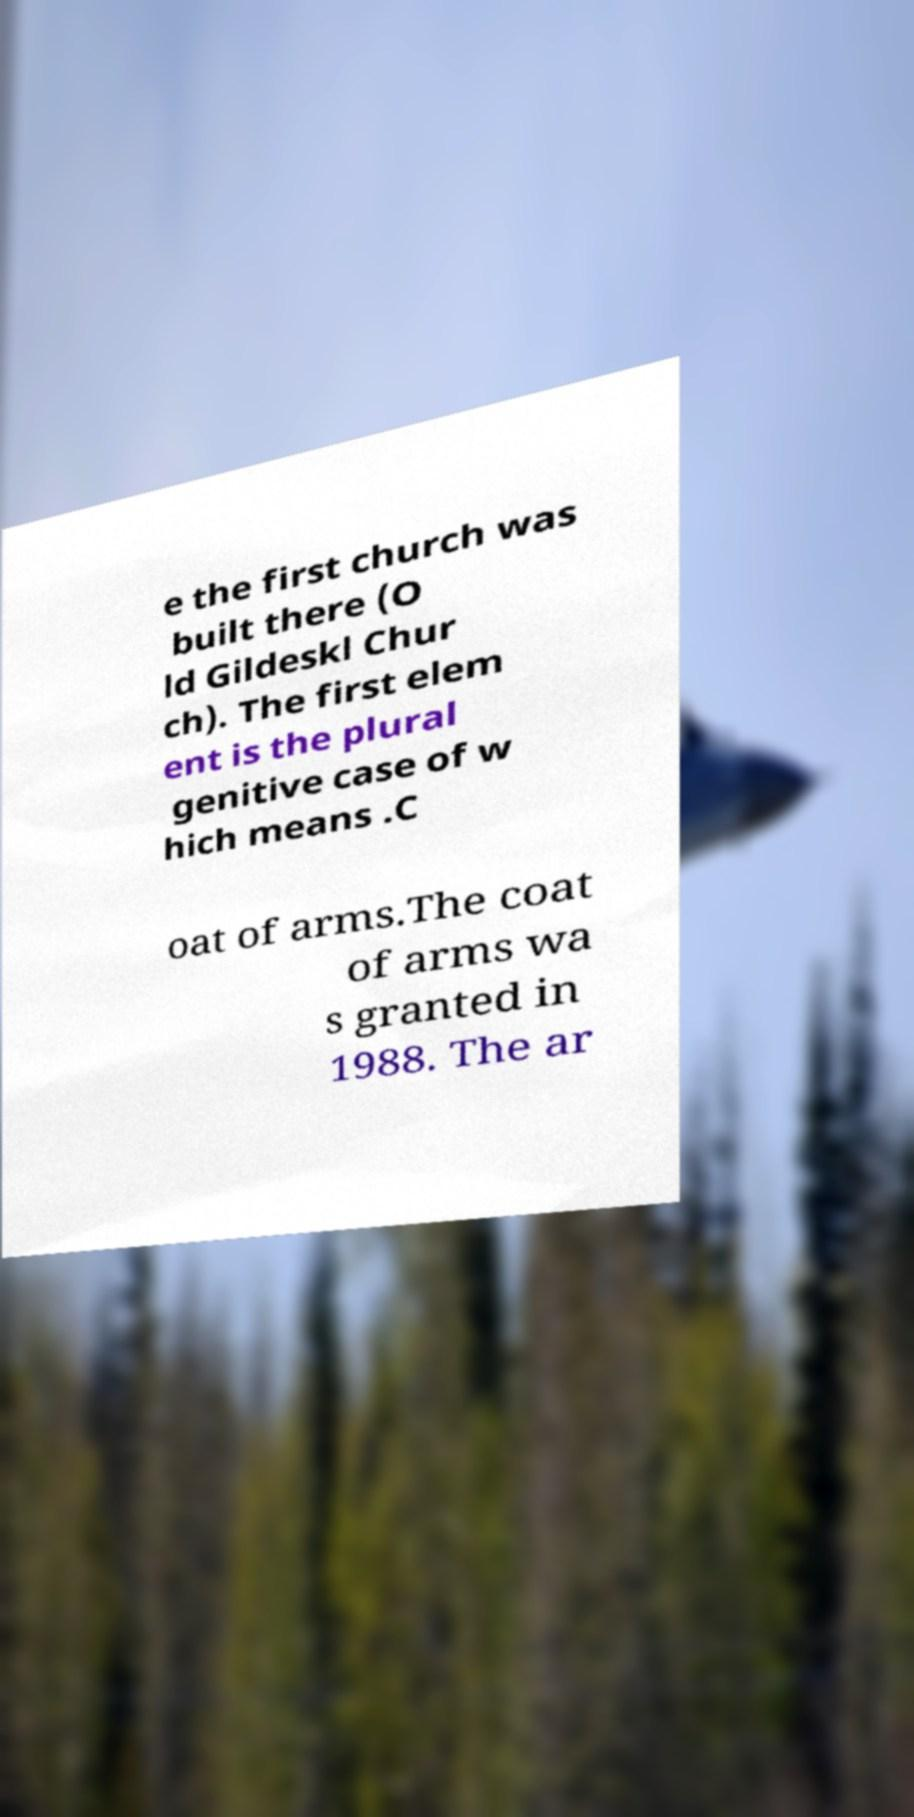Please read and relay the text visible in this image. What does it say? e the first church was built there (O ld Gildeskl Chur ch). The first elem ent is the plural genitive case of w hich means .C oat of arms.The coat of arms wa s granted in 1988. The ar 